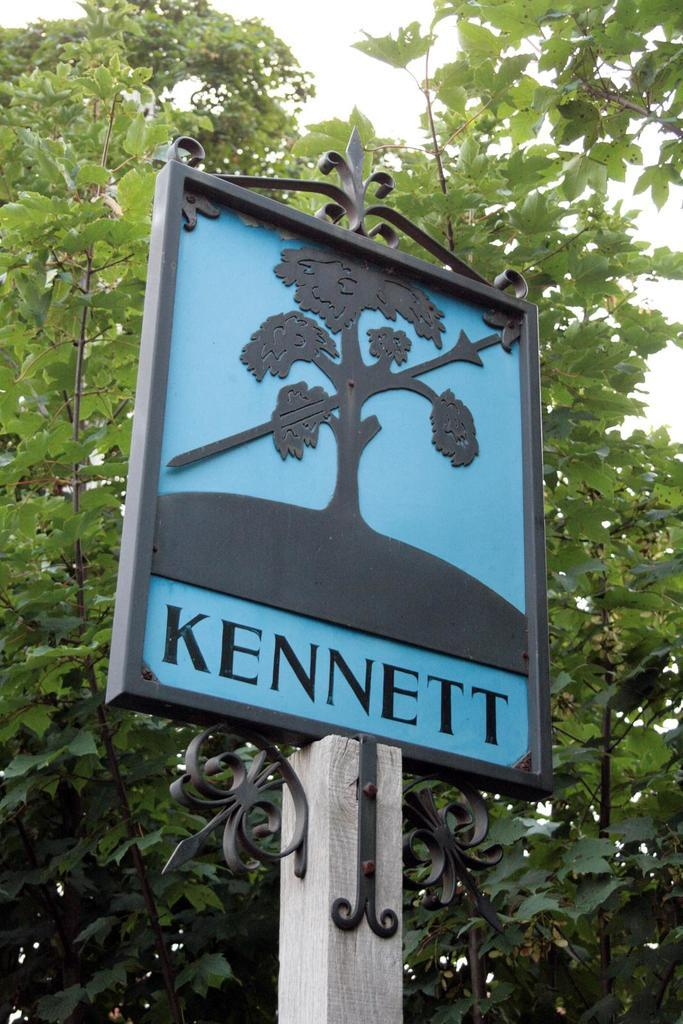What is the main object in the image? There is a pole in the image. What is attached to the top of the pole? There is a board with text and an image on top of the pole. What can be seen in the background of the image? There are trees in the background of the image. What type of mint plant can be seen growing on the pole in the image? There is no mint plant present on the pole in the image. What is the net used for in the image? There is no net present in the image. 